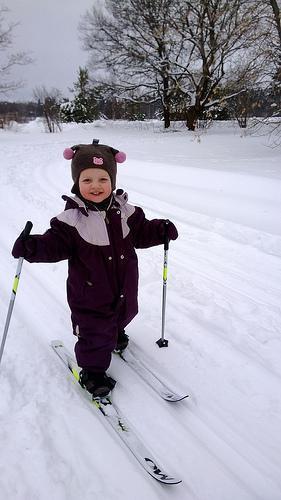How many teeth does the kid show?
Give a very brief answer. 2. 